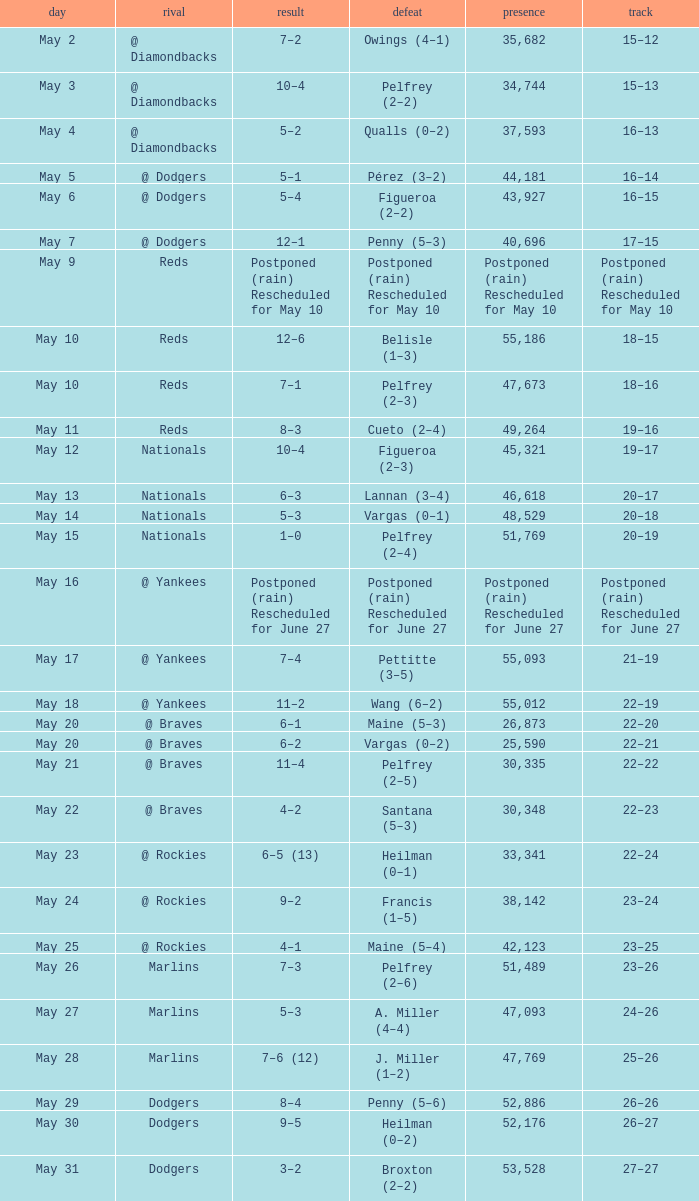Record of 22–20 involved what score? 6–1. 